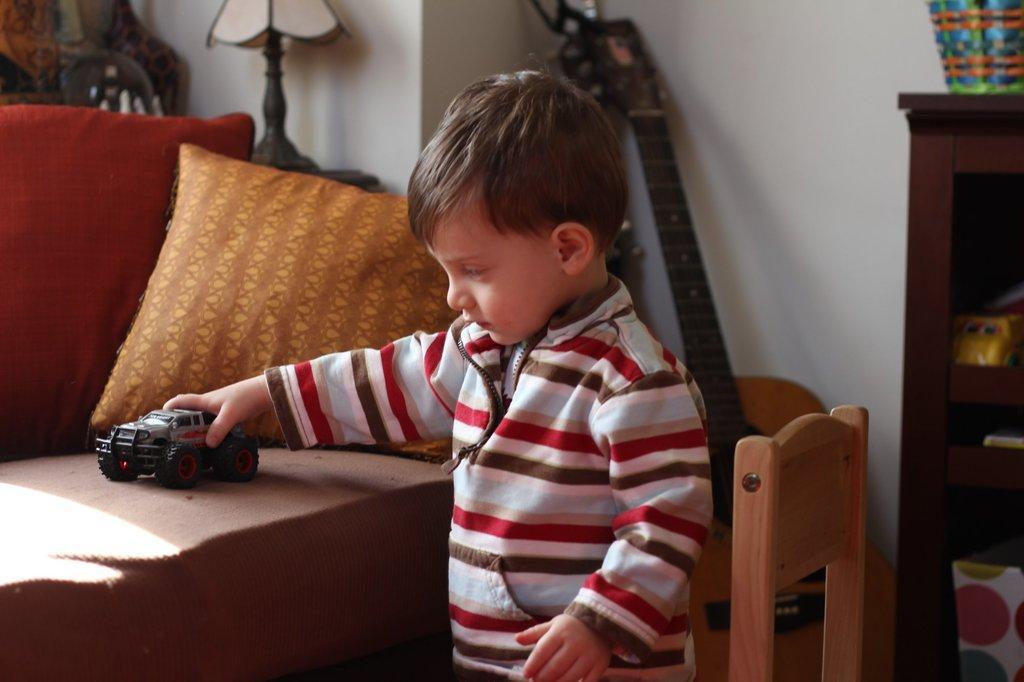How would you summarize this image in a sentence or two? In the given picture, I can see a child holding a car a remote car and behind a person i can see a wall and small wardrobe top of the wardrobe i can see a object and towards left top we can find another object which is placed here and a pillow. Finally we can find a chair. 